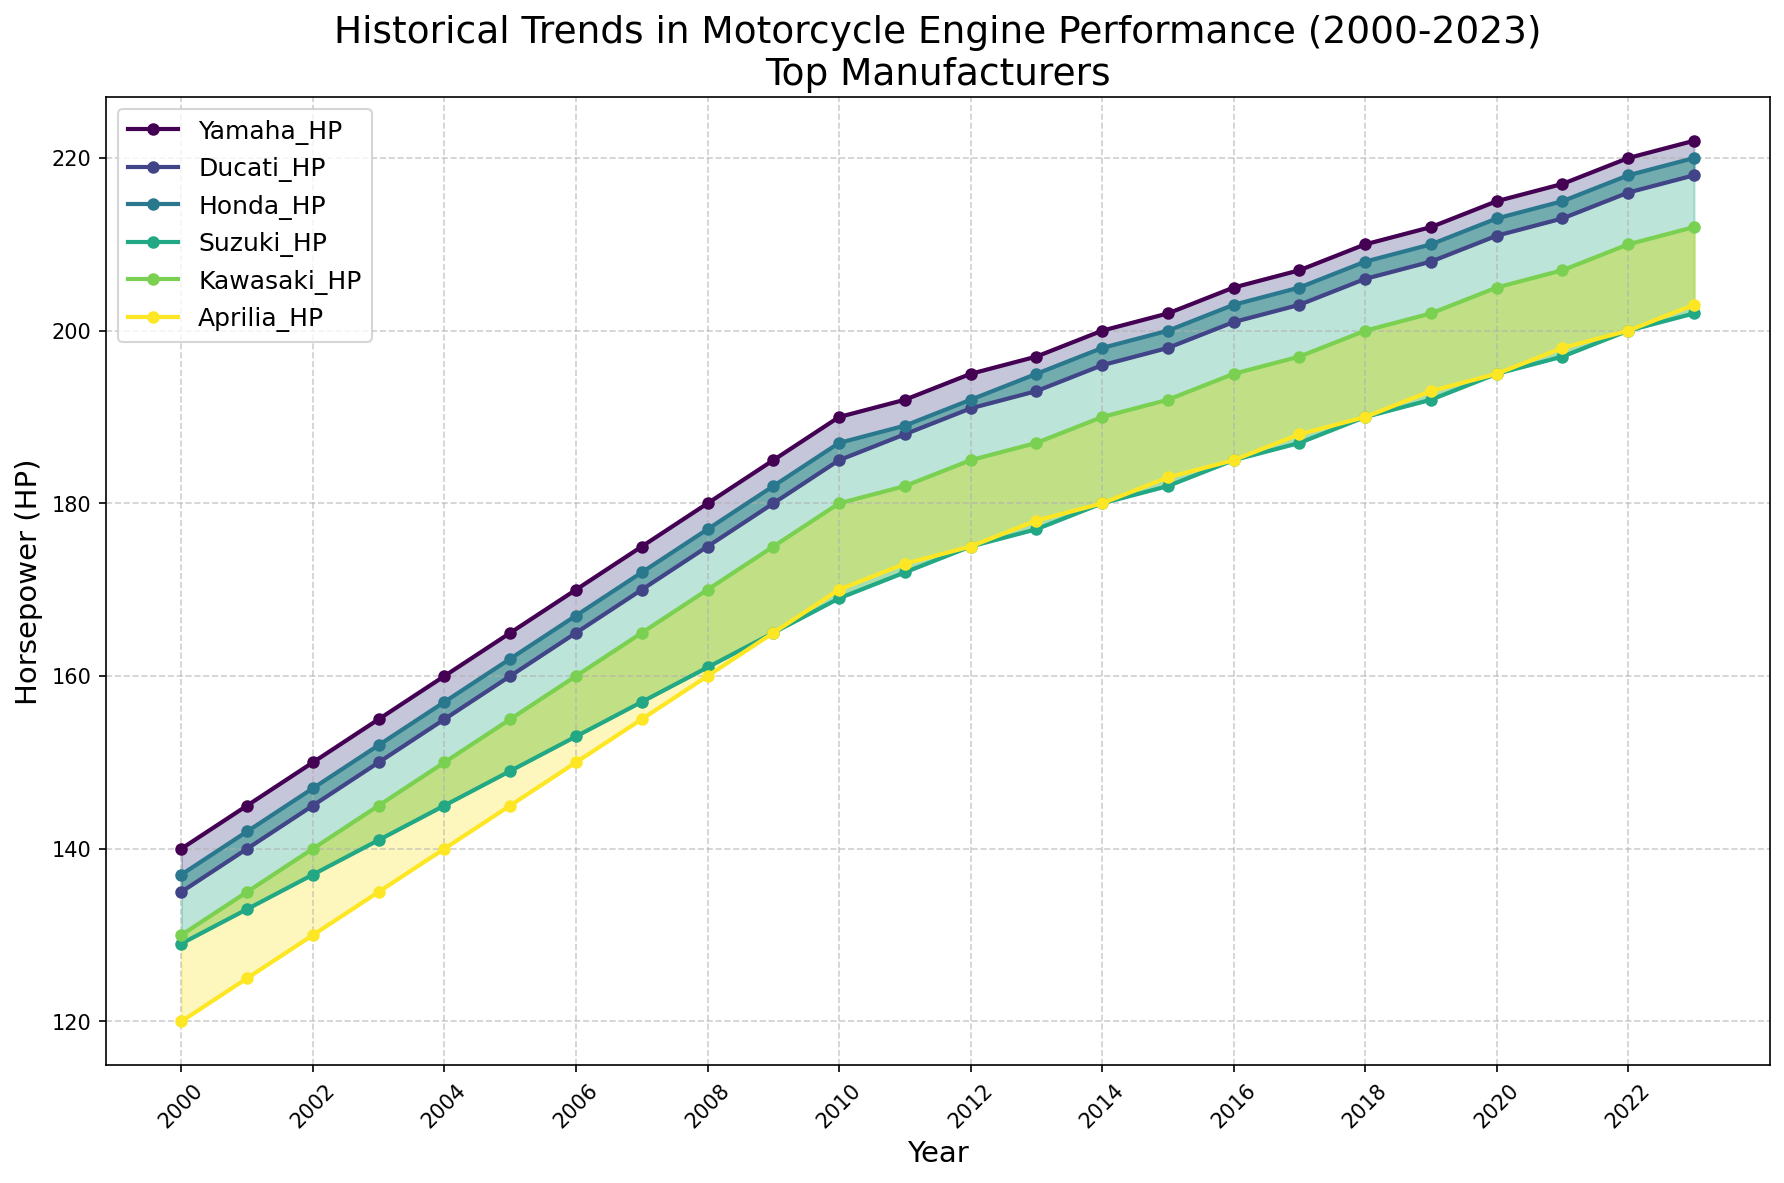Which manufacturer had the highest horsepower in 2023? To find the answer, look at the last data points for each manufacturer in the figure. The one with the highest value represents the manufacturer with the highest horsepower.
Answer: Yamaha How did Honda's horsepower trend change from 2000 to 2023? By observing the line representing Honda, note its starting value in 2000 and ending value in 2023. Interpret the direction and slope of the line to understand the trend.
Answer: Increased Which two manufacturers had the closest horsepower values in 2015? Identify the data points for all manufacturers in 2015 and compare them. The two manufacturers with the smallest difference in their horsepower values are the closest.
Answer: Yamaha and Honda What is the average increase in horsepower for Ducati between 2000 and 2023? First, find Ducati's horsepower in 2000 and 2023. Calculate the difference, then divide by the number of years (2023 - 2000) to find the average annual increase.
Answer: 3.65 HP/year Between which years did Kawasaki see the most significant horsepower increase? Examine Kawasaki's line and look for the segment with the steepest slope. Use the x-axis to identify the corresponding years.
Answer: 2018 to 2023 How does the horsepower improvement of Aprilia from 2000 to 2023 compare to Yamaha's? Determine the difference in horsepower for Aprilia (2023 vs. 2000) and for Yamaha over the same period. Compare these two values.
Answer: Less than Yamaha Which manufacturer had the least improvement in horsepower from 2000 to 2023? Calculate the difference between the 2000 and 2023 horsepower values for each manufacturer. The one with the smallest difference is the least improved.
Answer: Suzuki Does any manufacturer show a consistent linear growth trend in horsepower? Examine each manufacturer’s line on the chart to see if it consistently rises in a straight-line pattern across all years.
Answer: No What was the rate of horsepower growth for Yamaha from 2008 to 2013? Find the horsepower values for Yamaha in 2008 and 2013. Calculate the difference, then divide by the number of years (2013 - 2008) to determine the annual growth rate.
Answer: 2.2 HP/year 